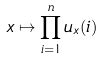<formula> <loc_0><loc_0><loc_500><loc_500>x \mapsto \prod _ { i = 1 } ^ { n } u _ { x } ( i )</formula> 